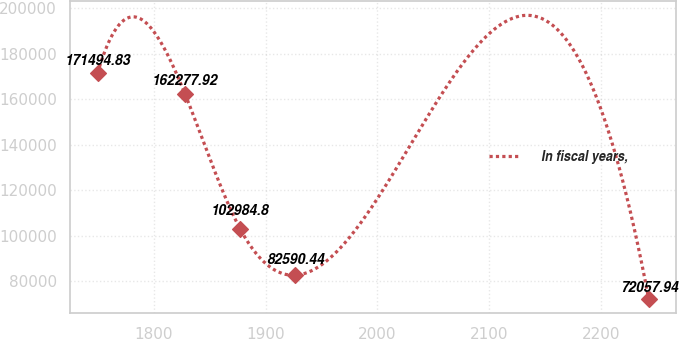Convert chart to OTSL. <chart><loc_0><loc_0><loc_500><loc_500><line_chart><ecel><fcel>In fiscal years,<nl><fcel>1749.54<fcel>171495<nl><fcel>1827.75<fcel>162278<nl><fcel>1877.08<fcel>102985<nl><fcel>1926.41<fcel>82590.4<nl><fcel>2242.88<fcel>72057.9<nl></chart> 